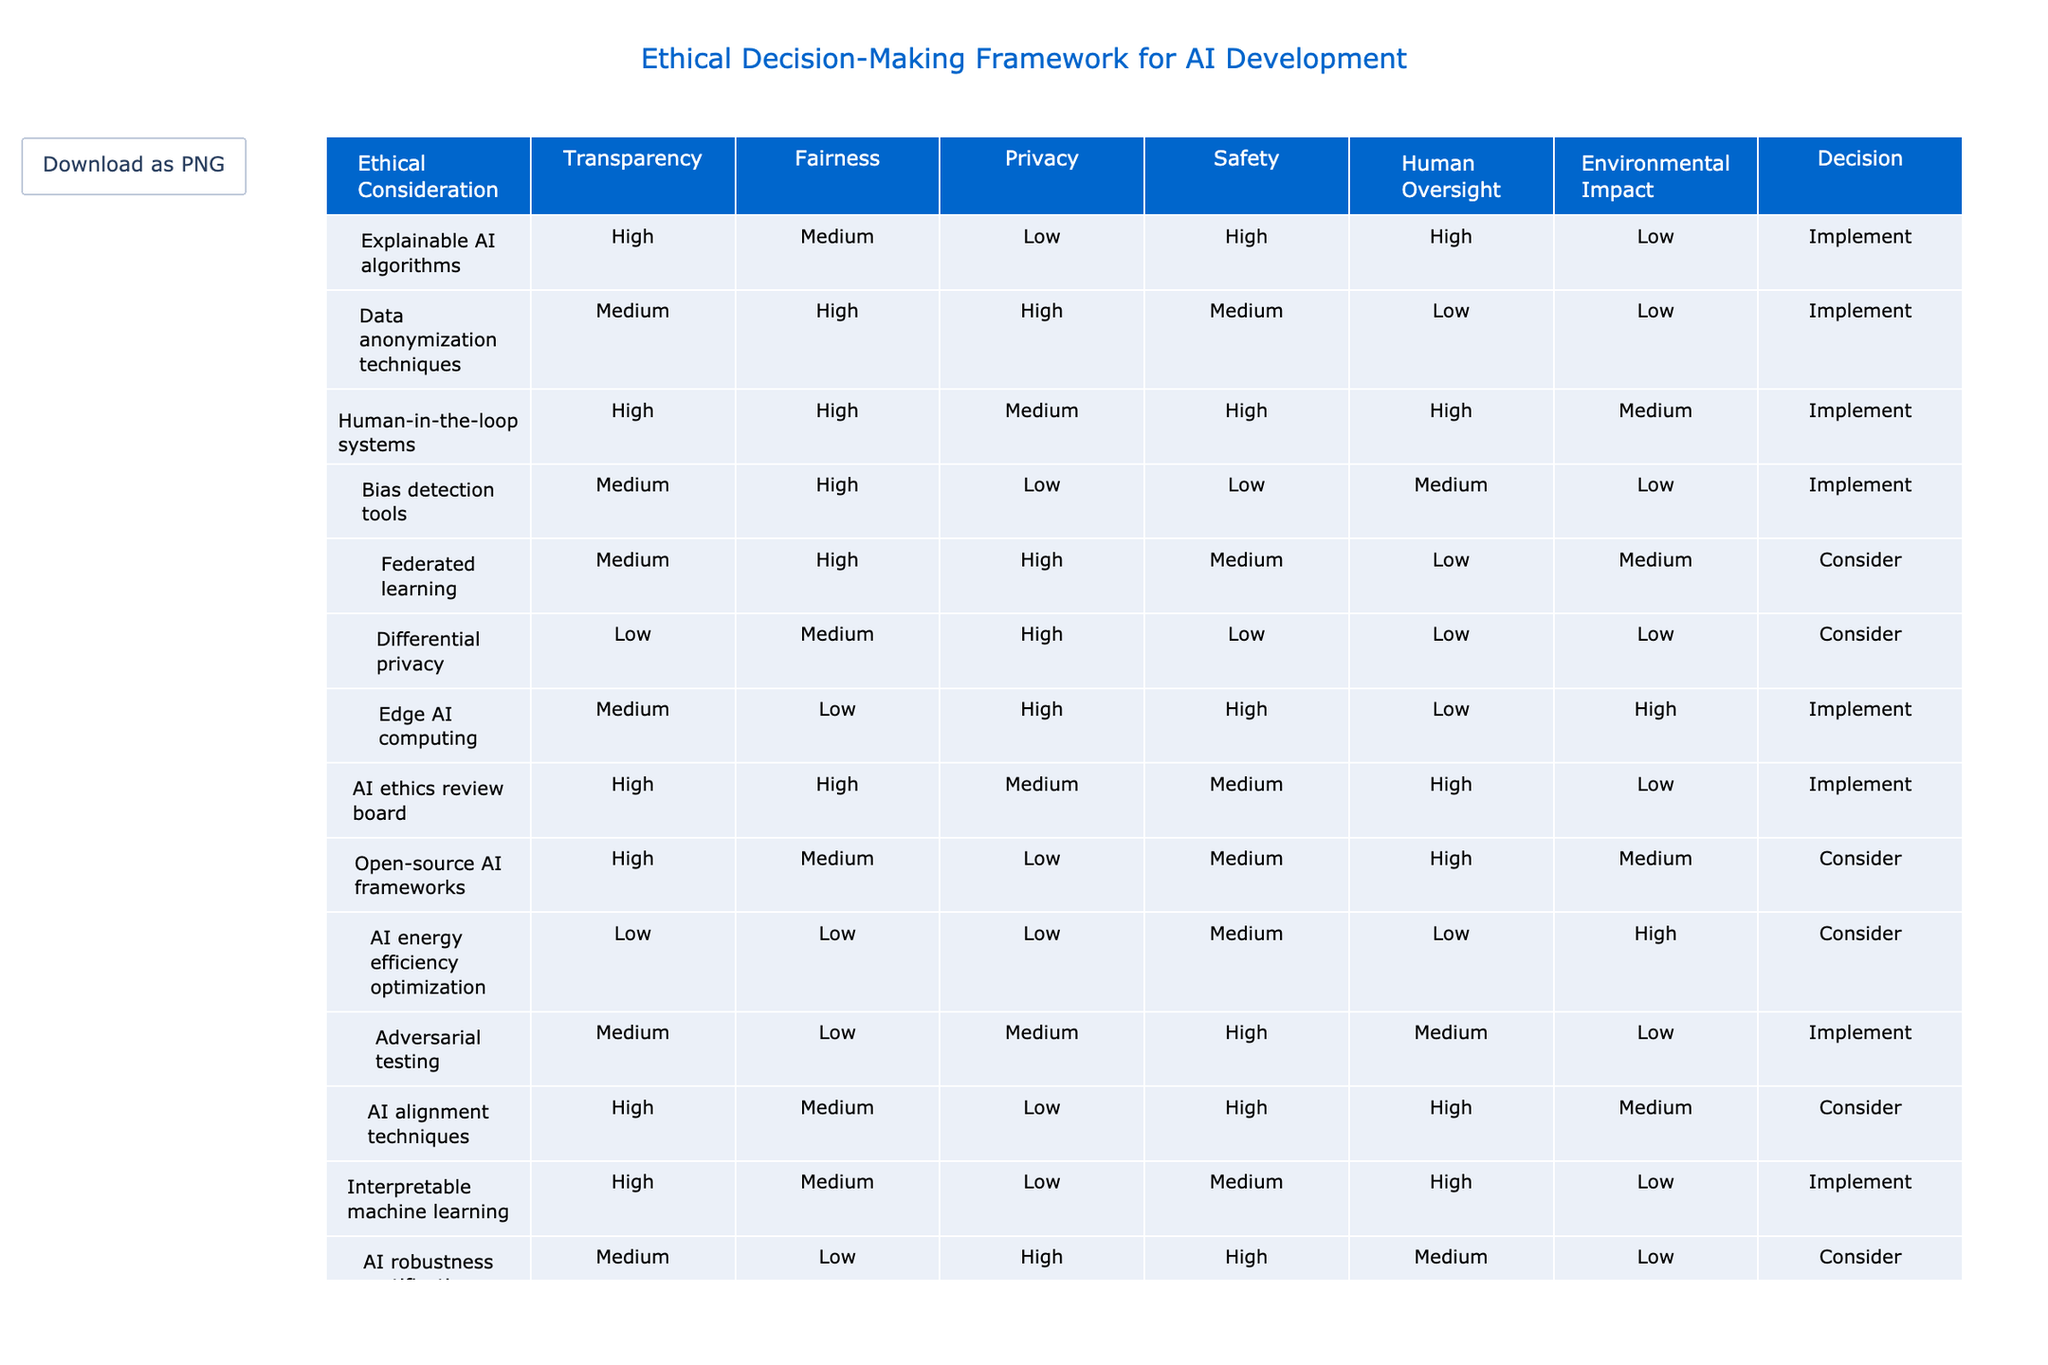What is the ethical consideration with the highest rating for Transparency? Looking at the Transparency column, "Explainable AI algorithms" has a rating of High, which is the highest compared to other considerations.
Answer: Explainable AI algorithms Which considerations have a rating of Low for Privacy? In the Privacy column, the considerations with a Low rating are "Explainable AI algorithms" and "Adversarial testing."
Answer: Explainable AI algorithms, Adversarial testing How many ethical considerations are rated Medium for Safety? From the Safety column, the considerations rated Medium are "Federated learning," "Open-source AI frameworks," "AI alignment techniques," and "Bias detection tools," totaling four considerations.
Answer: 4 Is "AI robustness certification" rated Medium for Fairness? Checking the Fairness column, "AI robustness certification" has a rating of Low, therefore it is not rated Medium for Fairness.
Answer: No What is the average rating for Environmental Impact across all ethical considerations? Summing the Environmental Impact ratings (Low, Low, Medium, Low, Medium, Low, High, Low, High, High, Medium) translates these into numerical values (Low=1, Medium=2, High=3) gives us: 1 + 1 + 2 + 1 + 2 + 1 + 3 + 1 + 3 + 3 + 2 = 20. Divided by 11 (total considerations), the average is approximately 1.82, which equals Medium.
Answer: Medium How many ethical considerations are rated High for Human Oversight? By examining the Human Oversight column, we find that "Explainable AI algorithms," "Human-in-the-loop systems," "AI ethics review board," and "Ethical AI training programs" all have a High rating, totaling four considerations.
Answer: 4 Which ethical considerations are recommended to implement due to a majority of High ratings? Looking through the table, "Explainable AI algorithms" and "Human-in-the-loop systems" stand out as they both receive High ratings in most categories, thus they are strongly recommended to implement.
Answer: Explainable AI algorithms, Human-in-the-loop systems Are there any considerations with a rating of Low in both Transparency and Fairness? Upon checking both columns, "Bias detection tools" is rated Low in both Transparency and Fairness, confirming that it meets the criteria of having Low ratings in both categories.
Answer: Yes What is the ethical consideration with the lowest total score when ratings for each category are summed? Evaluating the total scores: for each consideration, we sum the ratings represented as Low=1, Medium=2, High=3. "AI energy efficiency optimization," with scores of 1 + 1 + 1 + 2 + 1 + 3 = 9, has the lowest score among all considerations.
Answer: AI energy efficiency optimization 